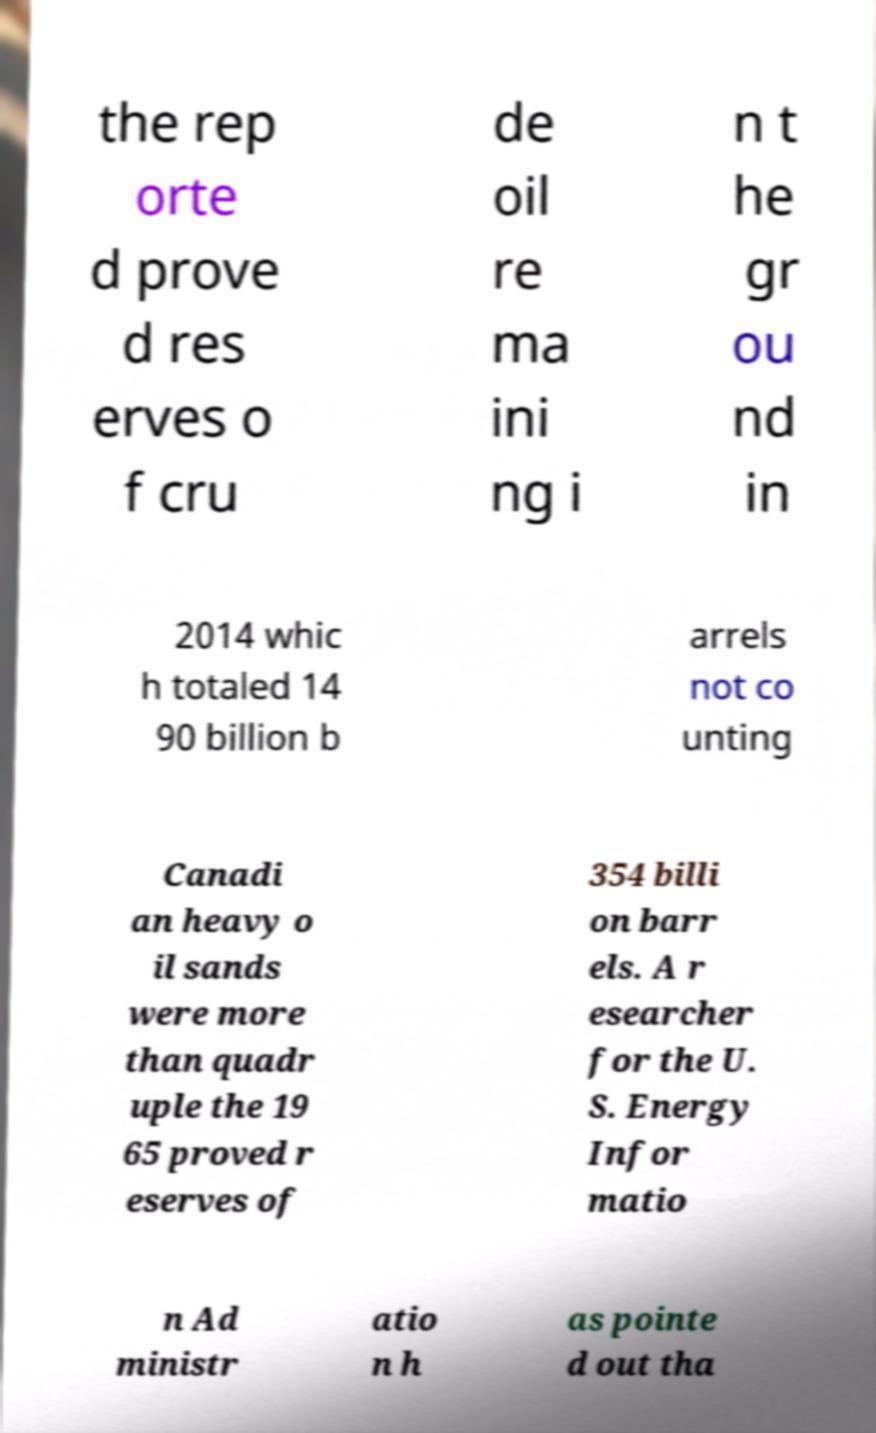There's text embedded in this image that I need extracted. Can you transcribe it verbatim? the rep orte d prove d res erves o f cru de oil re ma ini ng i n t he gr ou nd in 2014 whic h totaled 14 90 billion b arrels not co unting Canadi an heavy o il sands were more than quadr uple the 19 65 proved r eserves of 354 billi on barr els. A r esearcher for the U. S. Energy Infor matio n Ad ministr atio n h as pointe d out tha 